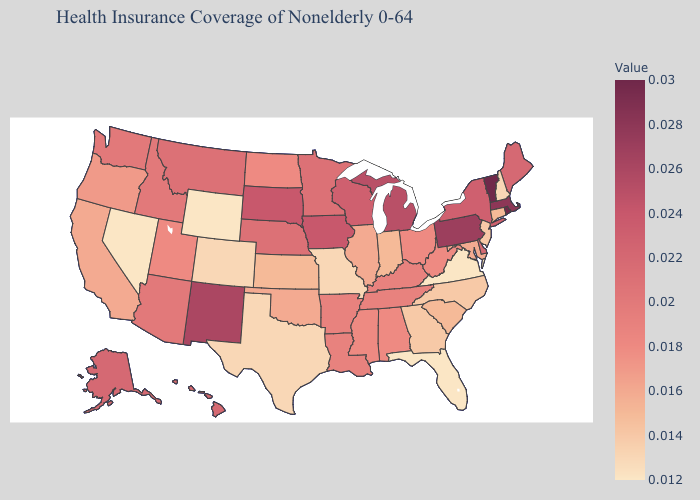Is the legend a continuous bar?
Be succinct. Yes. Does Vermont have the highest value in the USA?
Give a very brief answer. Yes. Among the states that border Missouri , does Oklahoma have the lowest value?
Answer briefly. No. Does Delaware have the highest value in the South?
Keep it brief. Yes. Does Delaware have the highest value in the South?
Concise answer only. Yes. Which states have the lowest value in the USA?
Write a very short answer. Florida, Nevada, Virginia, Wyoming. Does Colorado have the highest value in the West?
Short answer required. No. 